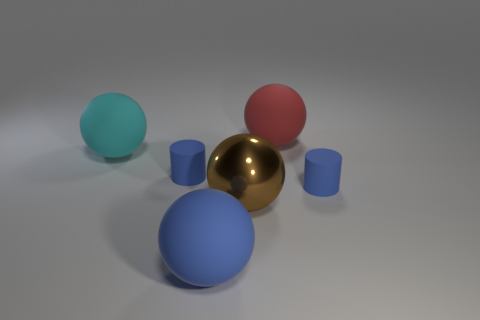How many objects are either large green blocks or rubber cylinders?
Your response must be concise. 2. Is there another large matte thing of the same shape as the big red matte object?
Offer a very short reply. Yes. How many brown objects are behind the large red ball?
Offer a very short reply. 0. What is the material of the cylinder that is to the left of the red ball that is to the right of the cyan rubber sphere?
Your answer should be very brief. Rubber. There is a blue thing that is the same size as the red rubber sphere; what is it made of?
Provide a succinct answer. Rubber. Are there any blue balls that have the same size as the cyan sphere?
Your answer should be compact. Yes. What color is the rubber sphere that is right of the big brown object?
Keep it short and to the point. Red. There is a big brown metal ball that is in front of the large red thing; is there a red thing to the right of it?
Your response must be concise. Yes. What number of other things are the same color as the large shiny object?
Your answer should be compact. 0. There is a blue rubber cylinder that is left of the brown shiny sphere; does it have the same size as the rubber object that is behind the large cyan matte object?
Make the answer very short. No. 